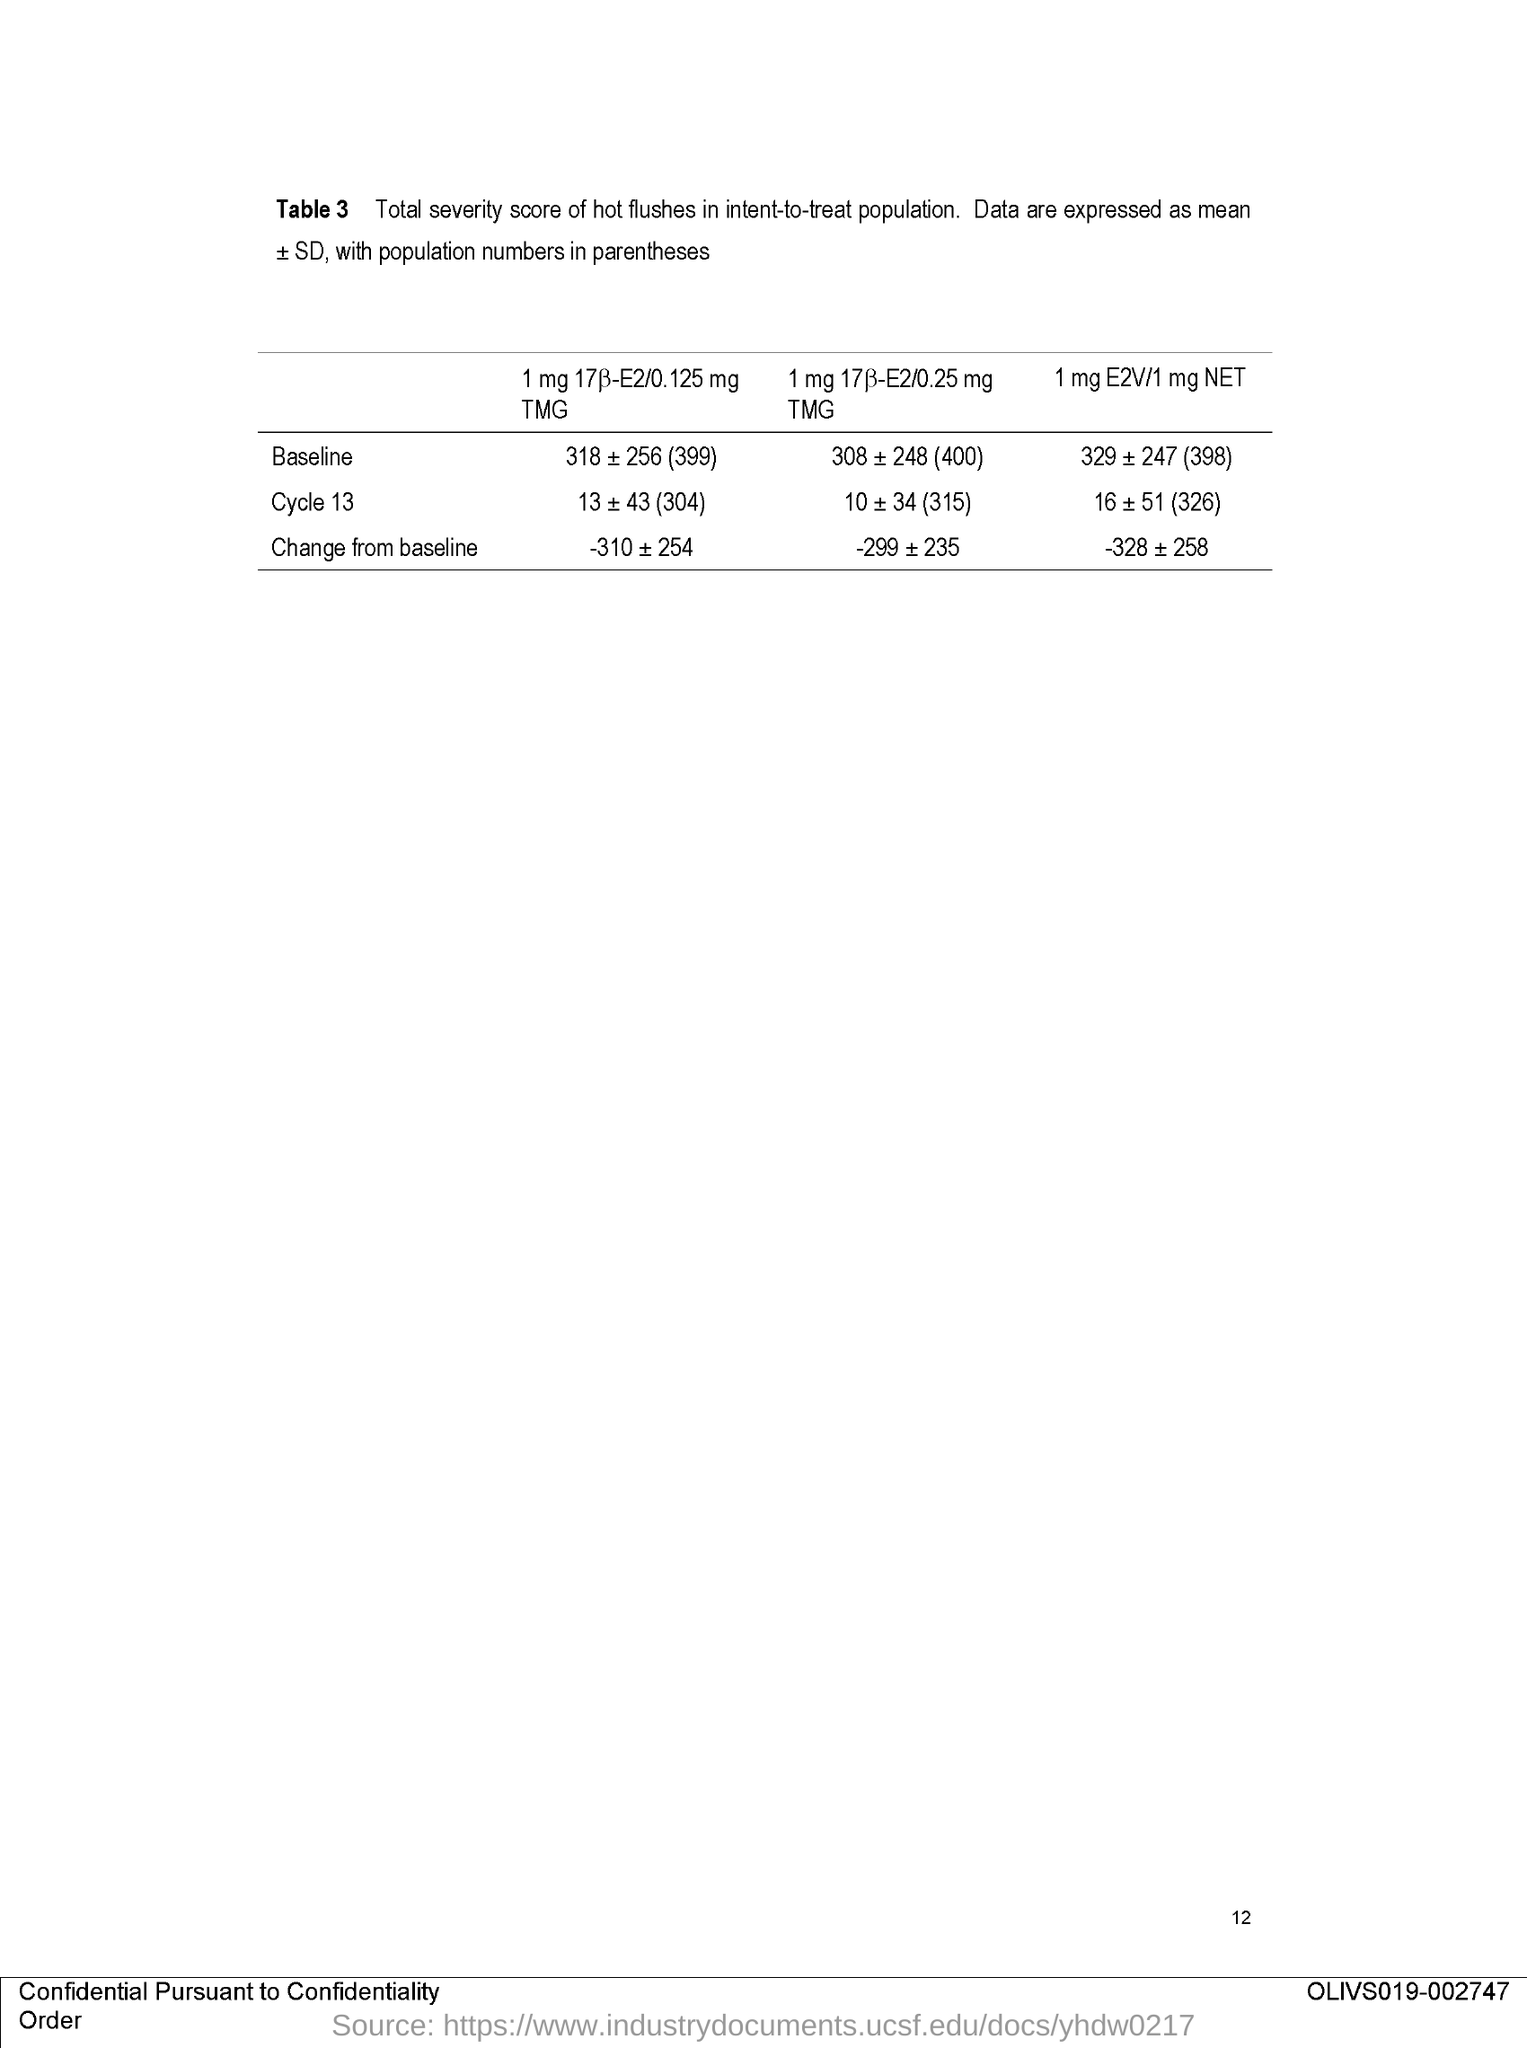List a handful of essential elements in this visual. The page number mentioned in this document is 12. The Table 3 in the document describes the total severity score of hot flushes in the intent-to-treat population, which represents all participants who were enrolled in the study and received at least one dose of the experimental drug or placebo. 